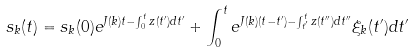<formula> <loc_0><loc_0><loc_500><loc_500>s _ { k } ( t ) = s _ { k } ( 0 ) e ^ { J ( { k } ) t - \int _ { 0 } ^ { t } z ( t ^ { \prime } ) d t ^ { \prime } } + \int _ { 0 } ^ { t } e ^ { J ( { k } ) ( t - t ^ { \prime } ) - \int _ { t ^ { \prime } } ^ { t } z ( t ^ { \prime \prime } ) d t ^ { \prime \prime } } \xi _ { k } ( t ^ { \prime } ) d t ^ { \prime }</formula> 